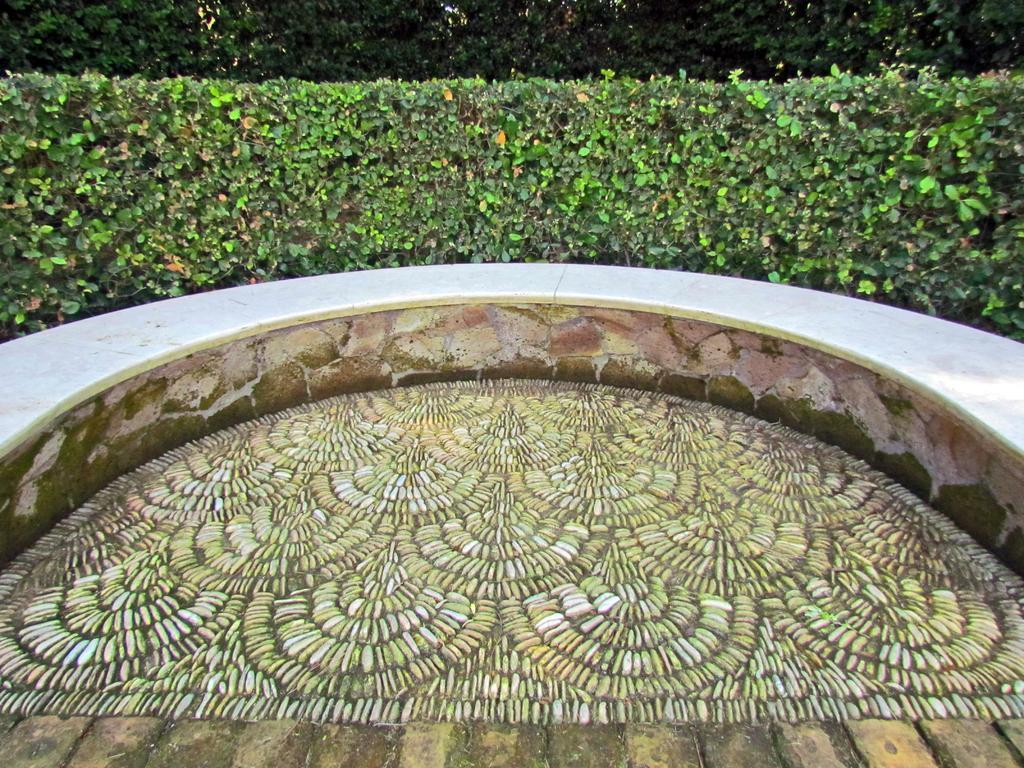Please provide a concise description of this image. In this image there is a floor on which there is some design. There is a circular wall around the floor. In the background there are plants. 